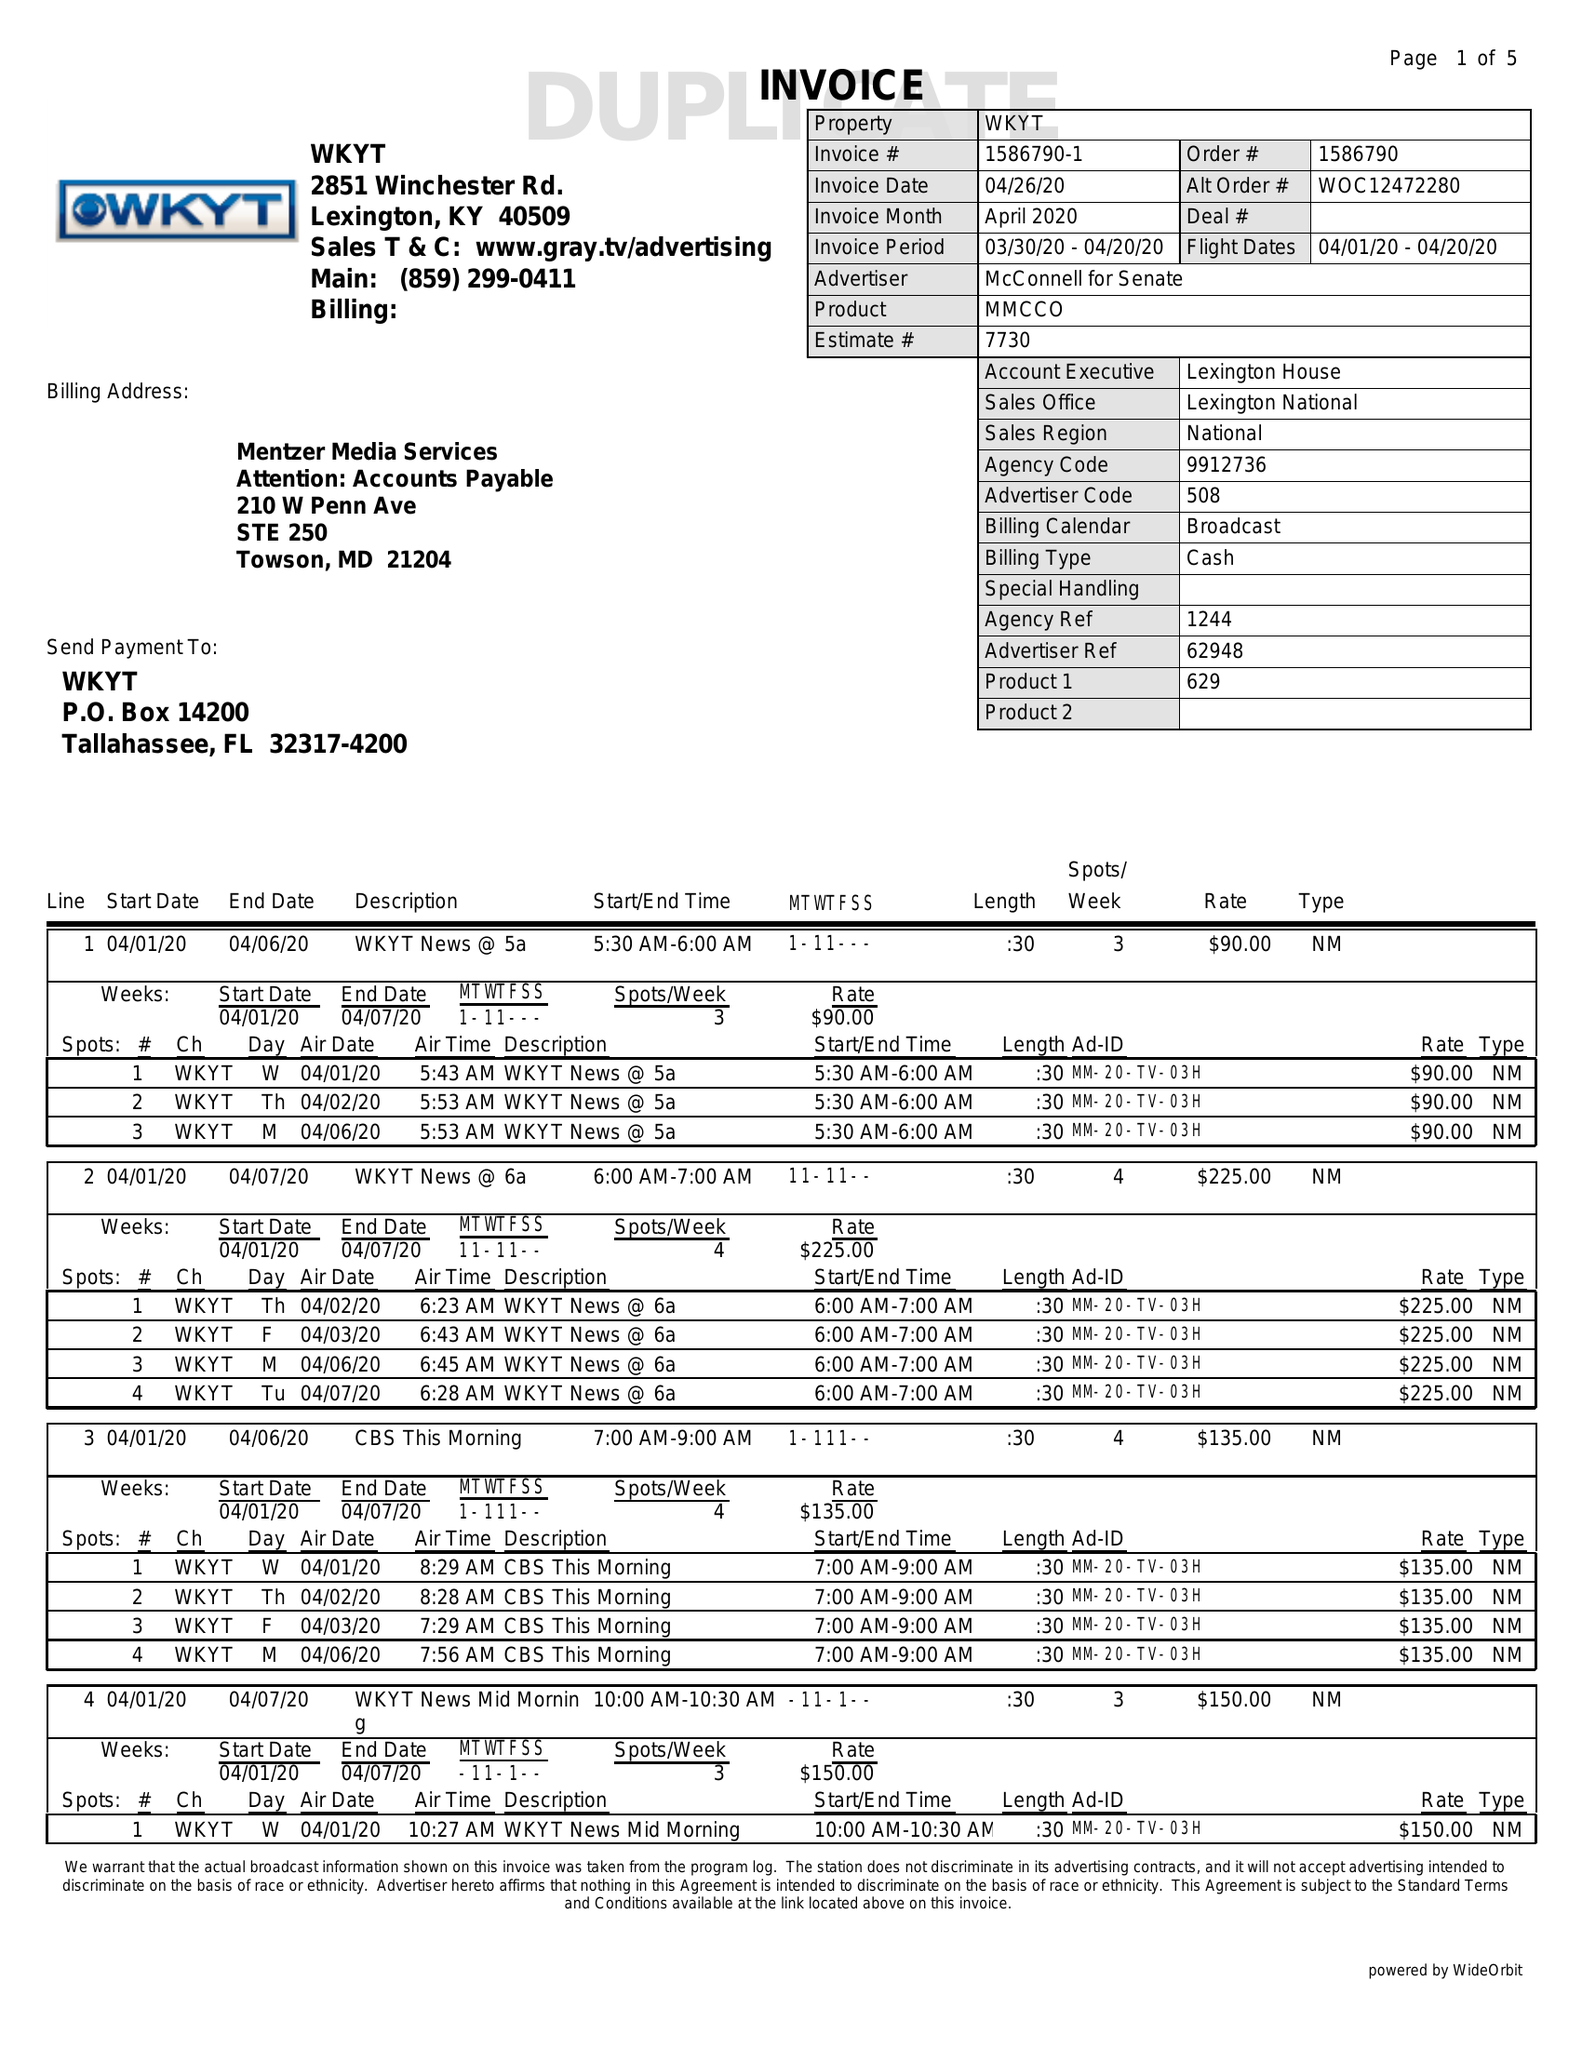What is the value for the contract_num?
Answer the question using a single word or phrase. 1586790 